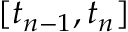<formula> <loc_0><loc_0><loc_500><loc_500>[ t _ { n - 1 } , t _ { n } ]</formula> 